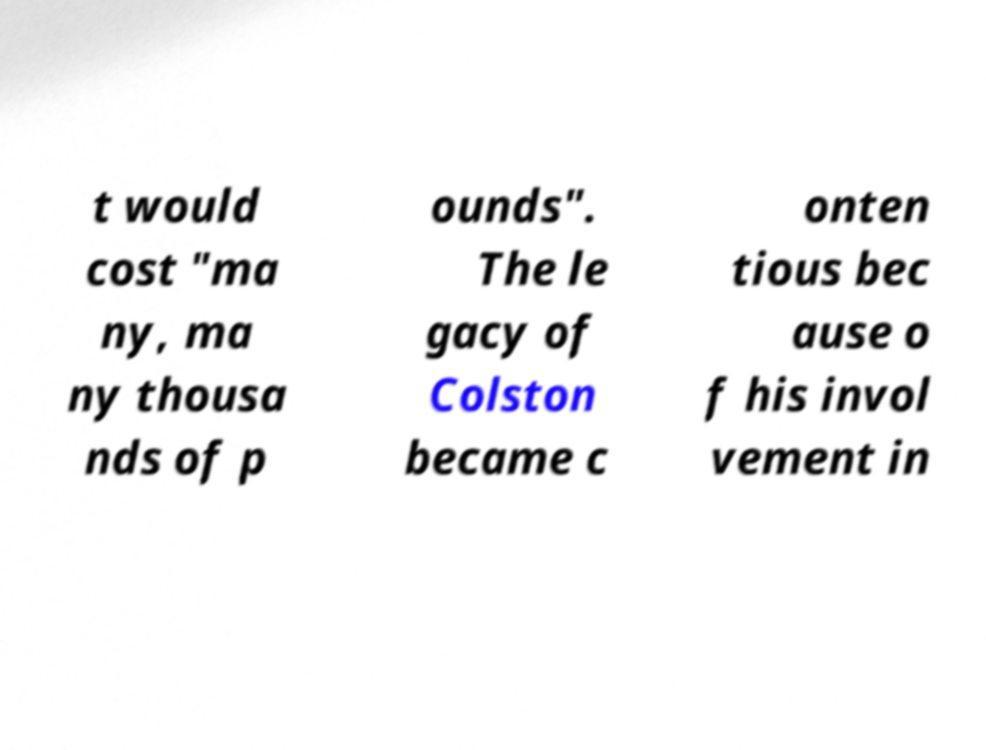Please identify and transcribe the text found in this image. t would cost "ma ny, ma ny thousa nds of p ounds". The le gacy of Colston became c onten tious bec ause o f his invol vement in 